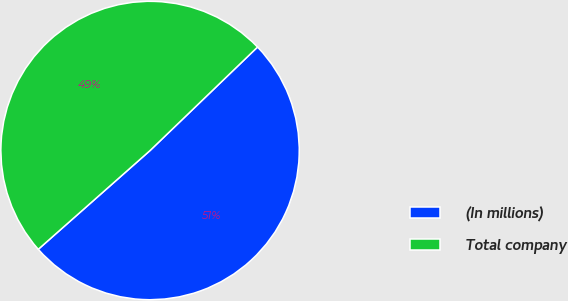Convert chart to OTSL. <chart><loc_0><loc_0><loc_500><loc_500><pie_chart><fcel>(In millions)<fcel>Total company<nl><fcel>50.68%<fcel>49.32%<nl></chart> 